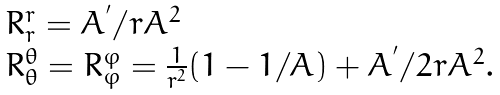Convert formula to latex. <formula><loc_0><loc_0><loc_500><loc_500>\begin{array} { l } R ^ { r } _ { r } = A ^ { ^ { \prime } } / r A ^ { 2 } \\ R ^ { \theta } _ { \theta } = R ^ { \varphi } _ { \varphi } = \frac { 1 } { r ^ { 2 } } ( 1 - 1 / A ) + A ^ { ^ { \prime } } / 2 r A ^ { 2 } . \end{array}</formula> 